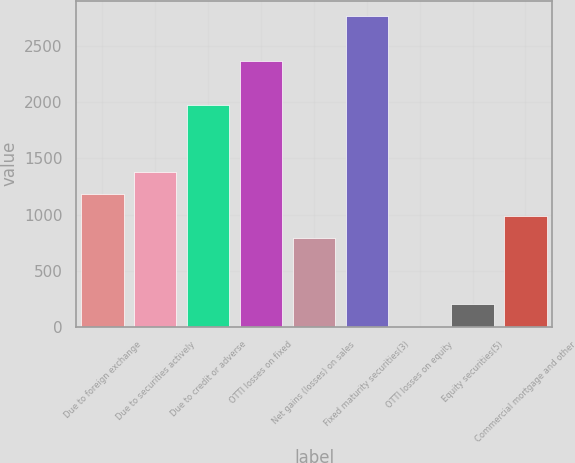Convert chart. <chart><loc_0><loc_0><loc_500><loc_500><bar_chart><fcel>Due to foreign exchange<fcel>Due to securities actively<fcel>Due to credit or adverse<fcel>OTTI losses on fixed<fcel>Net gains (losses) on sales<fcel>Fixed maturity securities(3)<fcel>OTTI losses on equity<fcel>Equity securities(5)<fcel>Commercial mortgage and other<nl><fcel>1186.28<fcel>1383.97<fcel>1977.04<fcel>2372.42<fcel>790.9<fcel>2767.8<fcel>0.14<fcel>197.83<fcel>988.59<nl></chart> 